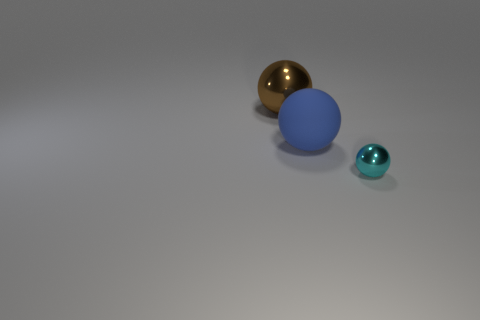How many other metallic objects are the same shape as the large metal object?
Your response must be concise. 1. Are there any tiny gray things that have the same material as the blue thing?
Provide a short and direct response. No. What number of green metallic cylinders are there?
Ensure brevity in your answer.  0. What number of spheres are either shiny objects or large brown objects?
Your answer should be compact. 2. There is a object that is the same size as the rubber sphere; what is its color?
Provide a short and direct response. Brown. How many balls are in front of the big brown ball and to the left of the cyan thing?
Provide a short and direct response. 1. What is the material of the cyan object?
Your response must be concise. Metal. How many objects are big brown things or cyan things?
Provide a short and direct response. 2. There is a metal object that is on the left side of the tiny ball; is it the same size as the metal object that is in front of the brown shiny thing?
Make the answer very short. No. How many other things are there of the same size as the brown metal sphere?
Your answer should be compact. 1. 